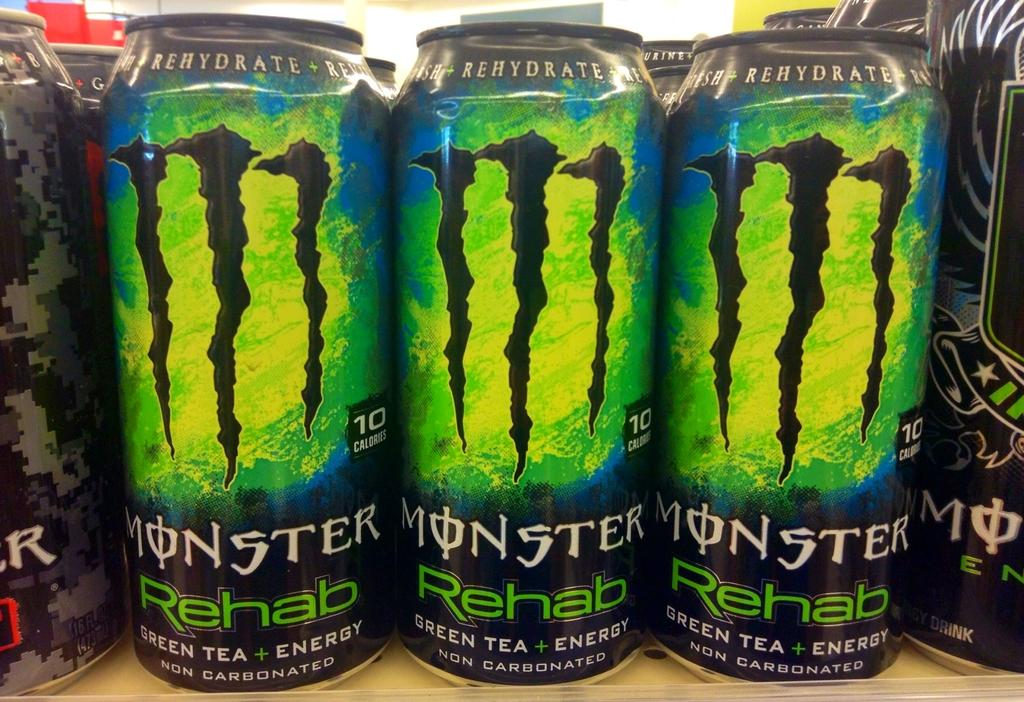<image>
Present a compact description of the photo's key features. many MONSTER Rehab Green tea energy drinks on display 